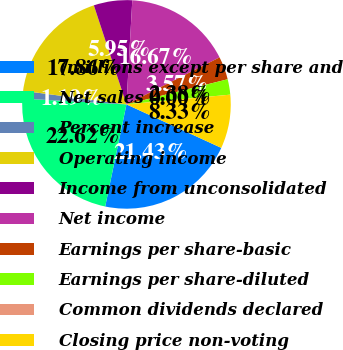Convert chart to OTSL. <chart><loc_0><loc_0><loc_500><loc_500><pie_chart><fcel>(millions except per share and<fcel>Net sales<fcel>Percent increase<fcel>Operating income<fcel>Income from unconsolidated<fcel>Net income<fcel>Earnings per share-basic<fcel>Earnings per share-diluted<fcel>Common dividends declared<fcel>Closing price non-voting<nl><fcel>21.42%<fcel>22.61%<fcel>1.19%<fcel>17.85%<fcel>5.95%<fcel>16.66%<fcel>3.57%<fcel>2.38%<fcel>0.0%<fcel>8.33%<nl></chart> 